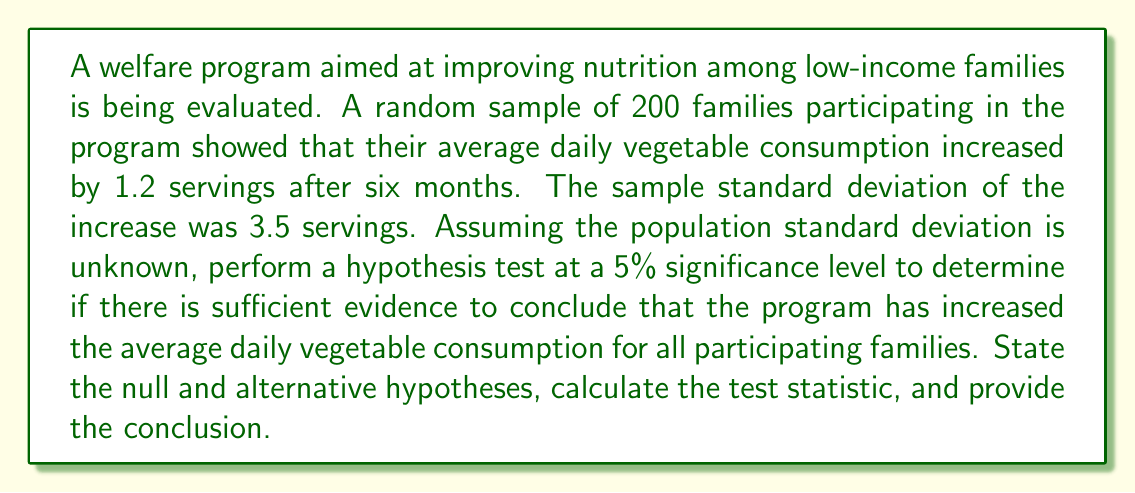What is the answer to this math problem? To analyze the effectiveness of this welfare program, we'll use a one-sample t-test. Let's break down the process step-by-step:

1. State the hypotheses:
   $H_0: \mu = 0$ (null hypothesis: the program has no effect on average daily vegetable consumption)
   $H_a: \mu > 0$ (alternative hypothesis: the program increases average daily vegetable consumption)

2. Choose the significance level:
   $\alpha = 0.05$ (5% significance level)

3. Calculate the test statistic:
   The formula for the t-statistic is:
   
   $$t = \frac{\bar{x} - \mu_0}{s/\sqrt{n}}$$
   
   Where:
   $\bar{x}$ = sample mean = 1.2
   $\mu_0$ = hypothesized population mean = 0
   $s$ = sample standard deviation = 3.5
   $n$ = sample size = 200

   Plugging in the values:
   
   $$t = \frac{1.2 - 0}{3.5/\sqrt{200}} = \frac{1.2}{3.5/14.14} = \frac{1.2}{0.2475} = 4.85$$

4. Determine the critical value:
   For a one-tailed test with $\alpha = 0.05$ and df = 199 (n-1), the critical t-value is approximately 1.653 (from t-distribution table).

5. Compare the test statistic to the critical value:
   Since 4.85 > 1.653, we reject the null hypothesis.

6. Calculate the p-value:
   Using a t-distribution calculator or table, we find that the p-value for t = 4.85 with df = 199 is p < 0.0001.

7. Conclusion:
   Since the p-value (< 0.0001) is less than the significance level (0.05), we reject the null hypothesis. There is strong statistical evidence to conclude that the welfare program has increased the average daily vegetable consumption for all participating families.
Answer: Reject the null hypothesis. There is sufficient evidence at the 5% significance level to conclude that the welfare program has increased the average daily vegetable consumption for all participating families (t = 4.85, p < 0.0001). 